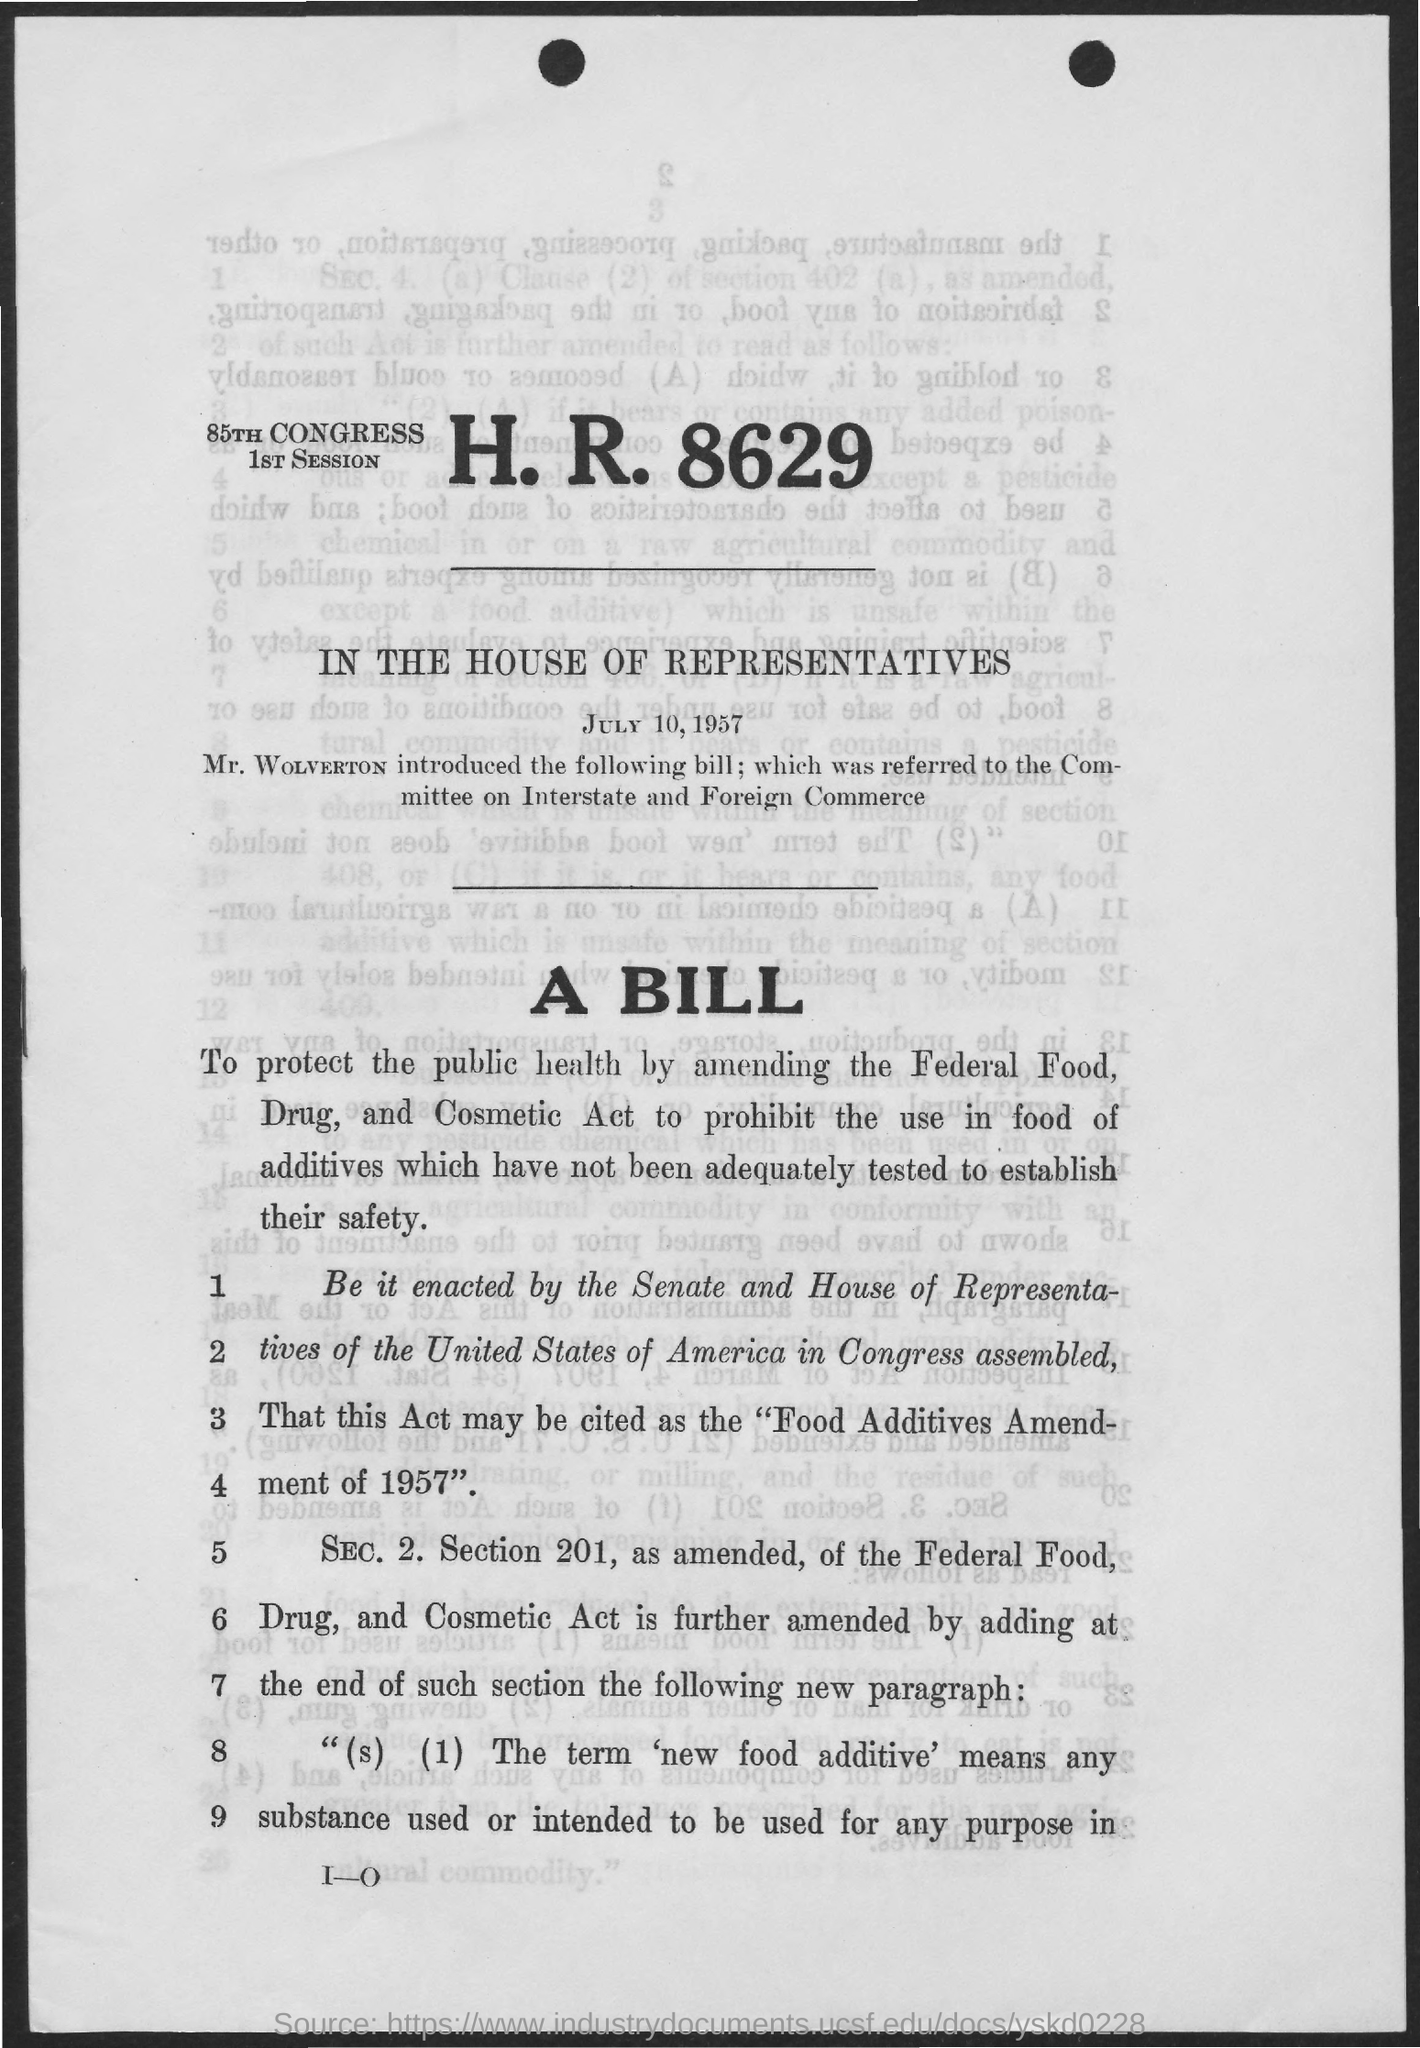Where is the 85th Congress going to be held?
Ensure brevity in your answer.  IN THE HOUSE OF REPRESENTATIVES. When is the 85th Congress going to be held?
Offer a terse response. JULY 10, 1957. Who introduced the bill?
Ensure brevity in your answer.  Mr. WOLVERTON. To whom was the bill referred to?
Offer a very short reply. Committee on Interstate and Foreign Commerce. What can this Act be cited as?
Provide a short and direct response. "Food Additives Amendment of 1957". 